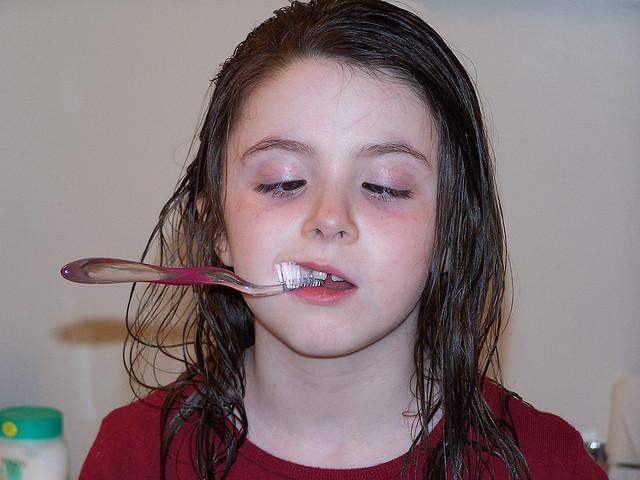How many bottles are pictured?
Give a very brief answer. 1. 